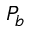Convert formula to latex. <formula><loc_0><loc_0><loc_500><loc_500>P _ { b }</formula> 